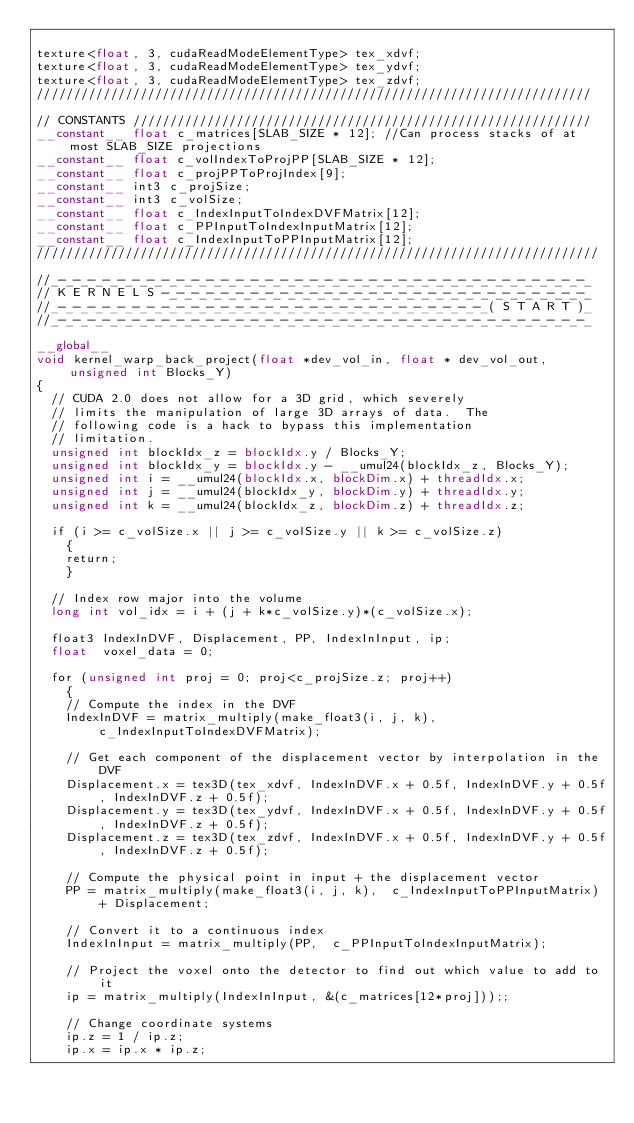<code> <loc_0><loc_0><loc_500><loc_500><_Cuda_>
texture<float, 3, cudaReadModeElementType> tex_xdvf;
texture<float, 3, cudaReadModeElementType> tex_ydvf;
texture<float, 3, cudaReadModeElementType> tex_zdvf;
///////////////////////////////////////////////////////////////////////////

// CONSTANTS //////////////////////////////////////////////////////////////
__constant__ float c_matrices[SLAB_SIZE * 12]; //Can process stacks of at most SLAB_SIZE projections
__constant__ float c_volIndexToProjPP[SLAB_SIZE * 12];
__constant__ float c_projPPToProjIndex[9];
__constant__ int3 c_projSize;
__constant__ int3 c_volSize;
__constant__ float c_IndexInputToIndexDVFMatrix[12];
__constant__ float c_PPInputToIndexInputMatrix[12];
__constant__ float c_IndexInputToPPInputMatrix[12];
////////////////////////////////////////////////////////////////////////////

//_-_-_-_-_-_-_-_-_-_-_-_-_-_-_-_-_-_-_-_-_-_-_-_-_-_-_-_-_-_-_-_-_-_-_-_-_
// K E R N E L S -_-_-_-_-_-_-_-_-_-_-_-_-_-_-_-_-_-_-_-_-_-_-_-_-_-_-_-_-_
//_-_-_-_-_-_-_-_-_-_-_-_-_-_-_-_-_-_-_-_-_-_-_-_-_-_-_-_-_-_( S T A R T )_
//_-_-_-_-_-_-_-_-_-_-_-_-_-_-_-_-_-_-_-_-_-_-_-_-_-_-_-_-_-_-_-_-_-_-_-_-_

__global__
void kernel_warp_back_project(float *dev_vol_in, float * dev_vol_out, unsigned int Blocks_Y)
{
  // CUDA 2.0 does not allow for a 3D grid, which severely
  // limits the manipulation of large 3D arrays of data.  The
  // following code is a hack to bypass this implementation
  // limitation.
  unsigned int blockIdx_z = blockIdx.y / Blocks_Y;
  unsigned int blockIdx_y = blockIdx.y - __umul24(blockIdx_z, Blocks_Y);
  unsigned int i = __umul24(blockIdx.x, blockDim.x) + threadIdx.x;
  unsigned int j = __umul24(blockIdx_y, blockDim.y) + threadIdx.y;
  unsigned int k = __umul24(blockIdx_z, blockDim.z) + threadIdx.z;

  if (i >= c_volSize.x || j >= c_volSize.y || k >= c_volSize.z)
    {
    return;
    }

  // Index row major into the volume
  long int vol_idx = i + (j + k*c_volSize.y)*(c_volSize.x);

  float3 IndexInDVF, Displacement, PP, IndexInInput, ip;
  float  voxel_data = 0;

  for (unsigned int proj = 0; proj<c_projSize.z; proj++)
    {
    // Compute the index in the DVF
    IndexInDVF = matrix_multiply(make_float3(i, j, k),  c_IndexInputToIndexDVFMatrix);

    // Get each component of the displacement vector by interpolation in the DVF
    Displacement.x = tex3D(tex_xdvf, IndexInDVF.x + 0.5f, IndexInDVF.y + 0.5f, IndexInDVF.z + 0.5f);
    Displacement.y = tex3D(tex_ydvf, IndexInDVF.x + 0.5f, IndexInDVF.y + 0.5f, IndexInDVF.z + 0.5f);
    Displacement.z = tex3D(tex_zdvf, IndexInDVF.x + 0.5f, IndexInDVF.y + 0.5f, IndexInDVF.z + 0.5f);

    // Compute the physical point in input + the displacement vector
    PP = matrix_multiply(make_float3(i, j, k),  c_IndexInputToPPInputMatrix) + Displacement;

    // Convert it to a continuous index
    IndexInInput = matrix_multiply(PP,  c_PPInputToIndexInputMatrix);

    // Project the voxel onto the detector to find out which value to add to it
    ip = matrix_multiply(IndexInInput, &(c_matrices[12*proj]));;

    // Change coordinate systems
    ip.z = 1 / ip.z;
    ip.x = ip.x * ip.z;</code> 